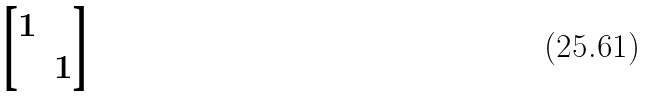Convert formula to latex. <formula><loc_0><loc_0><loc_500><loc_500>\begin{bmatrix} 1 & \\ & 1 \\ \end{bmatrix}</formula> 